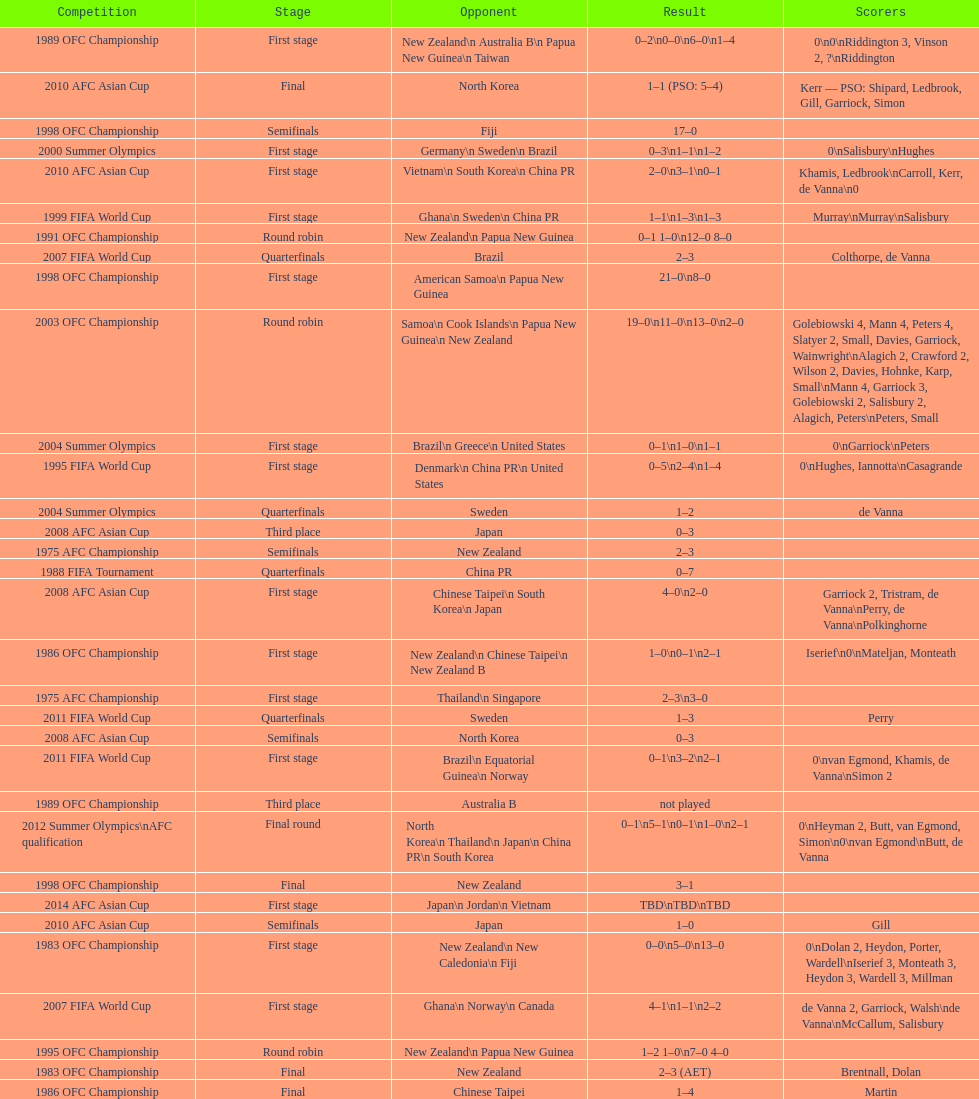In the 1983 ofc championship, how many goals were made in total? 18. 